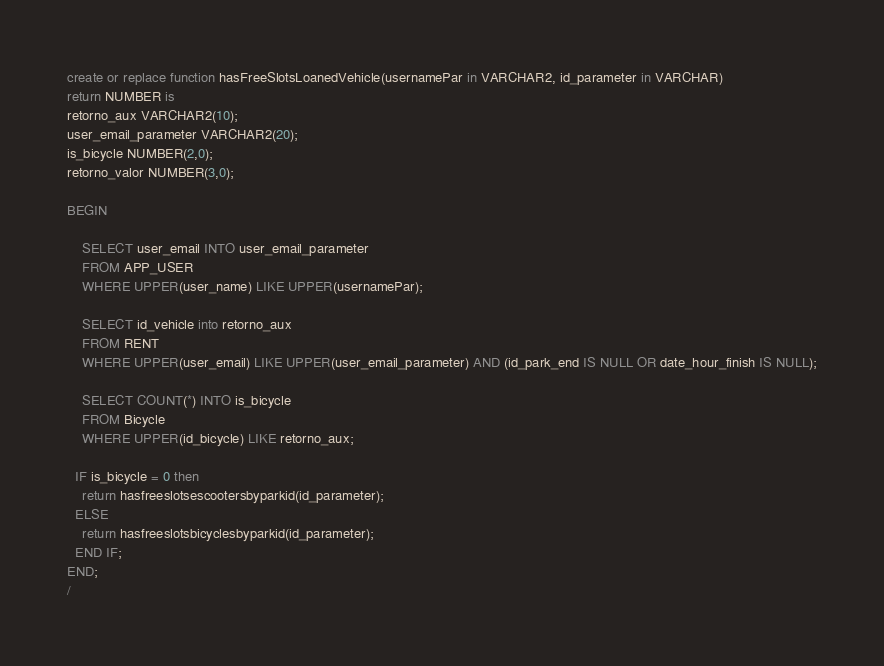Convert code to text. <code><loc_0><loc_0><loc_500><loc_500><_SQL_>create or replace function hasFreeSlotsLoanedVehicle(usernamePar in VARCHAR2, id_parameter in VARCHAR) 
return NUMBER is 
retorno_aux VARCHAR2(10);
user_email_parameter VARCHAR2(20);
is_bicycle NUMBER(2,0);
retorno_valor NUMBER(3,0);

BEGIN

    SELECT user_email INTO user_email_parameter
    FROM APP_USER
    WHERE UPPER(user_name) LIKE UPPER(usernamePar);

    SELECT id_vehicle into retorno_aux
    FROM RENT
    WHERE UPPER(user_email) LIKE UPPER(user_email_parameter) AND (id_park_end IS NULL OR date_hour_finish IS NULL);
    
    SELECT COUNT(*) INTO is_bicycle
    FROM Bicycle
    WHERE UPPER(id_bicycle) LIKE retorno_aux;

  IF is_bicycle = 0 then
    return hasfreeslotsescootersbyparkid(id_parameter);
  ELSE
    return hasfreeslotsbicyclesbyparkid(id_parameter);
  END IF;
END;
/
</code> 